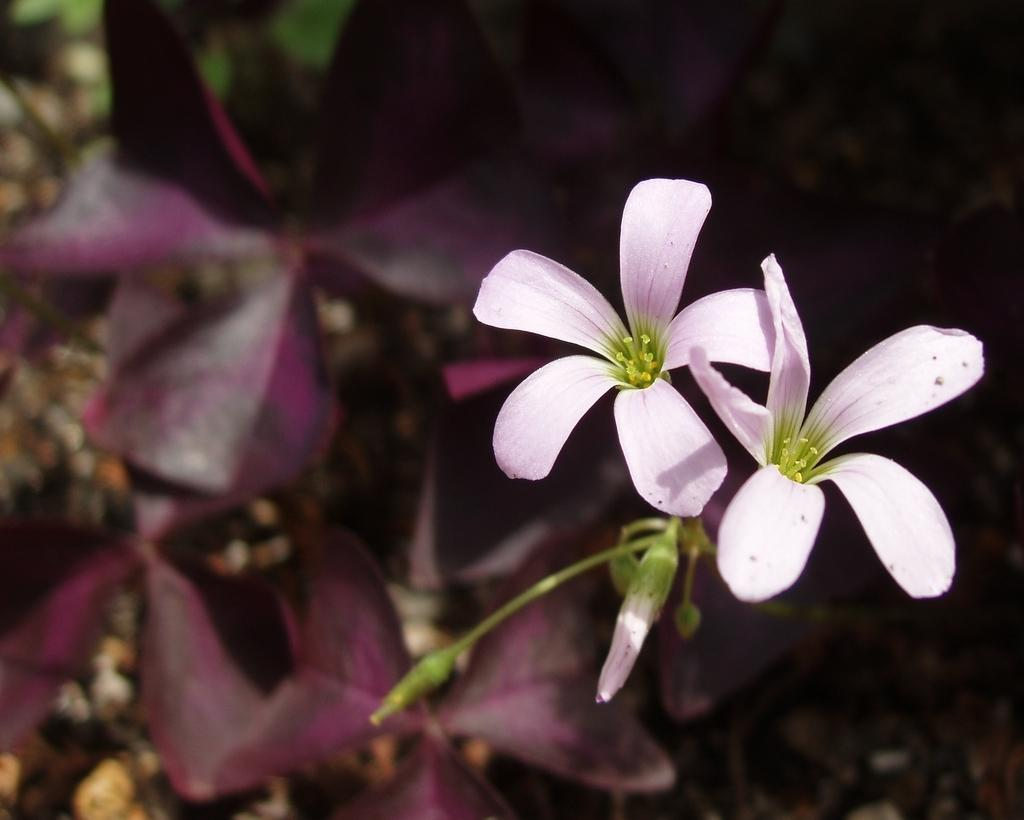How many flowers can be seen in the image? There are two flowers in the image. What can be observed about the background of the image? The background of the image is slightly blurred. What else is visible in the background besides the blurred area? There are plants and stones on the ground visible in the background. Is the coast visible in the image? No, the coast is not visible in the image; it features two flowers, a slightly blurred background, and plants and stones on the ground. 